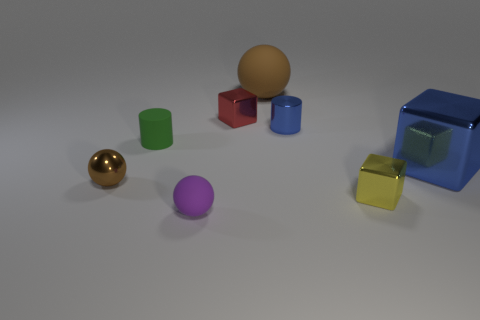Subtract all small cubes. How many cubes are left? 1 Add 2 metallic cubes. How many objects exist? 10 Subtract all purple balls. How many balls are left? 2 Subtract 3 spheres. How many spheres are left? 0 Subtract all red spheres. How many cyan cylinders are left? 0 Subtract all small green cylinders. Subtract all small metallic cylinders. How many objects are left? 6 Add 5 red objects. How many red objects are left? 6 Add 7 small purple balls. How many small purple balls exist? 8 Subtract 0 red cylinders. How many objects are left? 8 Subtract all cylinders. How many objects are left? 6 